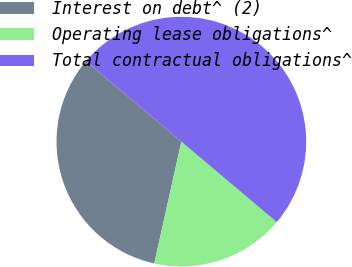<chart> <loc_0><loc_0><loc_500><loc_500><pie_chart><fcel>Interest on debt^ (2)<fcel>Operating lease obligations^<fcel>Total contractual obligations^<nl><fcel>32.67%<fcel>17.33%<fcel>50.0%<nl></chart> 